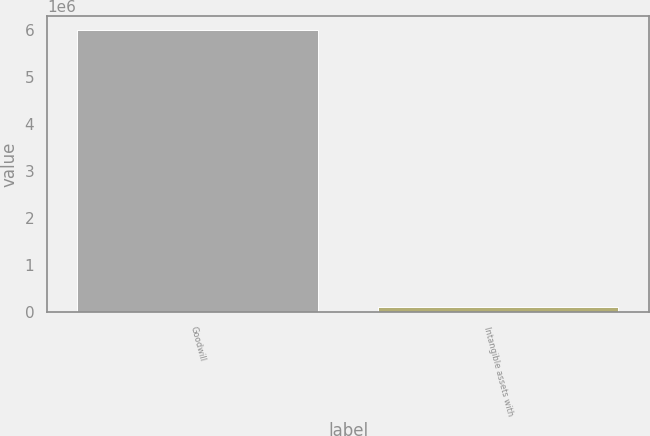<chart> <loc_0><loc_0><loc_500><loc_500><bar_chart><fcel>Goodwill<fcel>Intangible assets with<nl><fcel>6.00634e+06<fcel>103511<nl></chart> 